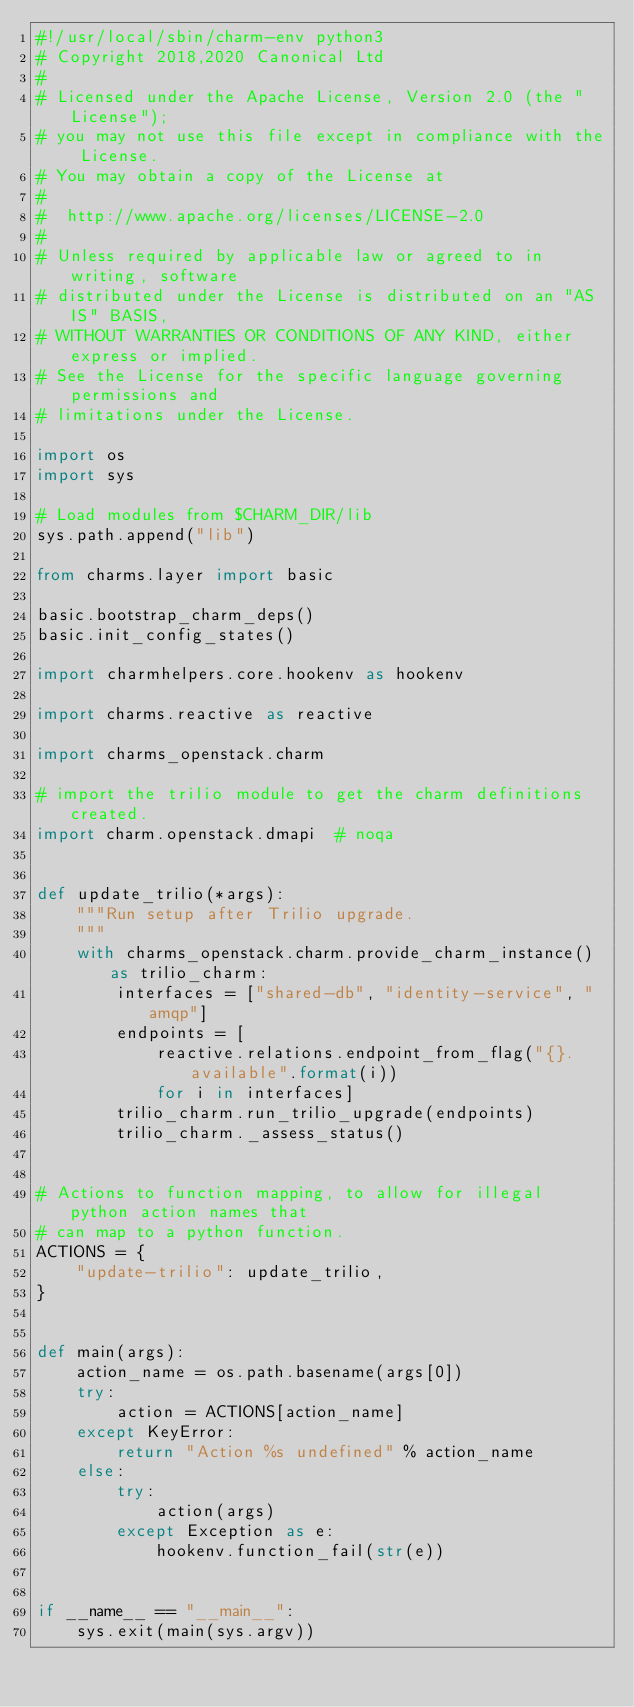Convert code to text. <code><loc_0><loc_0><loc_500><loc_500><_Python_>#!/usr/local/sbin/charm-env python3
# Copyright 2018,2020 Canonical Ltd
#
# Licensed under the Apache License, Version 2.0 (the "License");
# you may not use this file except in compliance with the License.
# You may obtain a copy of the License at
#
#  http://www.apache.org/licenses/LICENSE-2.0
#
# Unless required by applicable law or agreed to in writing, software
# distributed under the License is distributed on an "AS IS" BASIS,
# WITHOUT WARRANTIES OR CONDITIONS OF ANY KIND, either express or implied.
# See the License for the specific language governing permissions and
# limitations under the License.

import os
import sys

# Load modules from $CHARM_DIR/lib
sys.path.append("lib")

from charms.layer import basic

basic.bootstrap_charm_deps()
basic.init_config_states()

import charmhelpers.core.hookenv as hookenv

import charms.reactive as reactive

import charms_openstack.charm

# import the trilio module to get the charm definitions created.
import charm.openstack.dmapi  # noqa


def update_trilio(*args):
    """Run setup after Trilio upgrade.
    """
    with charms_openstack.charm.provide_charm_instance() as trilio_charm:
        interfaces = ["shared-db", "identity-service", "amqp"]
        endpoints = [
            reactive.relations.endpoint_from_flag("{}.available".format(i))
            for i in interfaces]
        trilio_charm.run_trilio_upgrade(endpoints)
        trilio_charm._assess_status()


# Actions to function mapping, to allow for illegal python action names that
# can map to a python function.
ACTIONS = {
    "update-trilio": update_trilio,
}


def main(args):
    action_name = os.path.basename(args[0])
    try:
        action = ACTIONS[action_name]
    except KeyError:
        return "Action %s undefined" % action_name
    else:
        try:
            action(args)
        except Exception as e:
            hookenv.function_fail(str(e))


if __name__ == "__main__":
    sys.exit(main(sys.argv))
</code> 